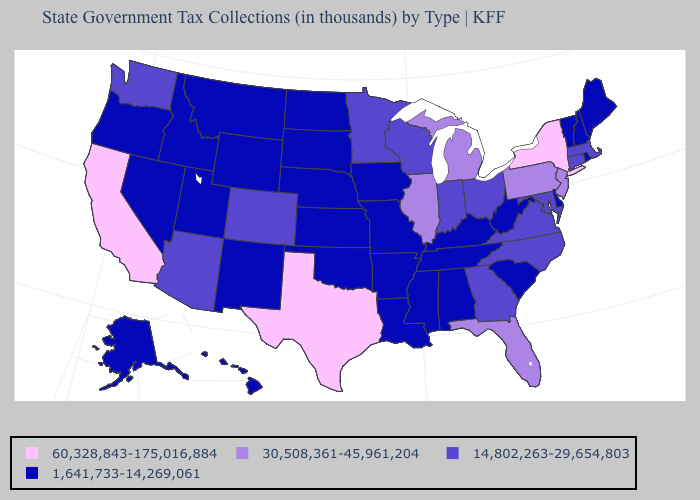Does Texas have the same value as New York?
Quick response, please. Yes. Name the states that have a value in the range 14,802,263-29,654,803?
Concise answer only. Arizona, Colorado, Connecticut, Georgia, Indiana, Maryland, Massachusetts, Minnesota, North Carolina, Ohio, Virginia, Washington, Wisconsin. Does Wisconsin have a lower value than Florida?
Short answer required. Yes. Which states have the lowest value in the USA?
Keep it brief. Alabama, Alaska, Arkansas, Delaware, Hawaii, Idaho, Iowa, Kansas, Kentucky, Louisiana, Maine, Mississippi, Missouri, Montana, Nebraska, Nevada, New Hampshire, New Mexico, North Dakota, Oklahoma, Oregon, Rhode Island, South Carolina, South Dakota, Tennessee, Utah, Vermont, West Virginia, Wyoming. Name the states that have a value in the range 30,508,361-45,961,204?
Be succinct. Florida, Illinois, Michigan, New Jersey, Pennsylvania. Does the map have missing data?
Concise answer only. No. Name the states that have a value in the range 14,802,263-29,654,803?
Keep it brief. Arizona, Colorado, Connecticut, Georgia, Indiana, Maryland, Massachusetts, Minnesota, North Carolina, Ohio, Virginia, Washington, Wisconsin. Name the states that have a value in the range 30,508,361-45,961,204?
Quick response, please. Florida, Illinois, Michigan, New Jersey, Pennsylvania. How many symbols are there in the legend?
Write a very short answer. 4. What is the highest value in states that border Georgia?
Short answer required. 30,508,361-45,961,204. What is the value of Connecticut?
Quick response, please. 14,802,263-29,654,803. Does the map have missing data?
Short answer required. No. What is the value of Mississippi?
Short answer required. 1,641,733-14,269,061. Does the first symbol in the legend represent the smallest category?
Give a very brief answer. No. Name the states that have a value in the range 14,802,263-29,654,803?
Give a very brief answer. Arizona, Colorado, Connecticut, Georgia, Indiana, Maryland, Massachusetts, Minnesota, North Carolina, Ohio, Virginia, Washington, Wisconsin. 